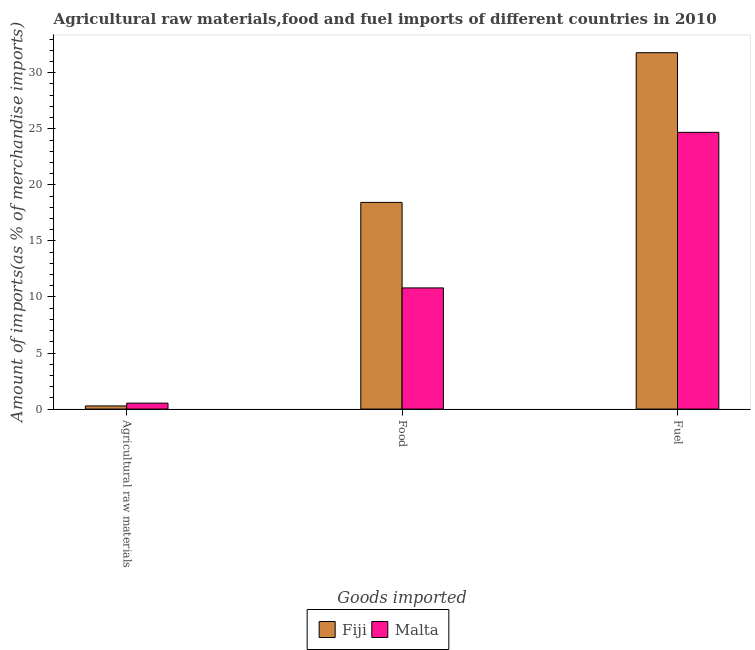How many groups of bars are there?
Give a very brief answer. 3. Are the number of bars per tick equal to the number of legend labels?
Your answer should be compact. Yes. How many bars are there on the 3rd tick from the left?
Your answer should be compact. 2. How many bars are there on the 2nd tick from the right?
Offer a very short reply. 2. What is the label of the 1st group of bars from the left?
Offer a terse response. Agricultural raw materials. What is the percentage of fuel imports in Fiji?
Your response must be concise. 31.79. Across all countries, what is the maximum percentage of raw materials imports?
Your response must be concise. 0.53. Across all countries, what is the minimum percentage of raw materials imports?
Offer a very short reply. 0.28. In which country was the percentage of raw materials imports maximum?
Your answer should be very brief. Malta. In which country was the percentage of raw materials imports minimum?
Keep it short and to the point. Fiji. What is the total percentage of food imports in the graph?
Make the answer very short. 29.24. What is the difference between the percentage of raw materials imports in Malta and that in Fiji?
Offer a very short reply. 0.25. What is the difference between the percentage of fuel imports in Fiji and the percentage of raw materials imports in Malta?
Your answer should be very brief. 31.26. What is the average percentage of raw materials imports per country?
Your answer should be very brief. 0.41. What is the difference between the percentage of raw materials imports and percentage of fuel imports in Malta?
Make the answer very short. -24.15. What is the ratio of the percentage of fuel imports in Malta to that in Fiji?
Make the answer very short. 0.78. Is the percentage of food imports in Malta less than that in Fiji?
Ensure brevity in your answer.  Yes. What is the difference between the highest and the second highest percentage of food imports?
Offer a terse response. 7.63. What is the difference between the highest and the lowest percentage of food imports?
Offer a very short reply. 7.63. In how many countries, is the percentage of fuel imports greater than the average percentage of fuel imports taken over all countries?
Your answer should be very brief. 1. What does the 2nd bar from the left in Food represents?
Provide a succinct answer. Malta. What does the 2nd bar from the right in Agricultural raw materials represents?
Your answer should be compact. Fiji. How many bars are there?
Provide a succinct answer. 6. Are all the bars in the graph horizontal?
Make the answer very short. No. What is the difference between two consecutive major ticks on the Y-axis?
Your answer should be compact. 5. Are the values on the major ticks of Y-axis written in scientific E-notation?
Keep it short and to the point. No. Does the graph contain grids?
Your answer should be very brief. No. Where does the legend appear in the graph?
Your answer should be compact. Bottom center. How many legend labels are there?
Your answer should be compact. 2. What is the title of the graph?
Keep it short and to the point. Agricultural raw materials,food and fuel imports of different countries in 2010. What is the label or title of the X-axis?
Keep it short and to the point. Goods imported. What is the label or title of the Y-axis?
Offer a very short reply. Amount of imports(as % of merchandise imports). What is the Amount of imports(as % of merchandise imports) of Fiji in Agricultural raw materials?
Your answer should be very brief. 0.28. What is the Amount of imports(as % of merchandise imports) of Malta in Agricultural raw materials?
Offer a very short reply. 0.53. What is the Amount of imports(as % of merchandise imports) in Fiji in Food?
Your response must be concise. 18.43. What is the Amount of imports(as % of merchandise imports) of Malta in Food?
Offer a very short reply. 10.81. What is the Amount of imports(as % of merchandise imports) in Fiji in Fuel?
Provide a succinct answer. 31.79. What is the Amount of imports(as % of merchandise imports) of Malta in Fuel?
Your answer should be compact. 24.68. Across all Goods imported, what is the maximum Amount of imports(as % of merchandise imports) of Fiji?
Your answer should be compact. 31.79. Across all Goods imported, what is the maximum Amount of imports(as % of merchandise imports) in Malta?
Offer a terse response. 24.68. Across all Goods imported, what is the minimum Amount of imports(as % of merchandise imports) of Fiji?
Make the answer very short. 0.28. Across all Goods imported, what is the minimum Amount of imports(as % of merchandise imports) of Malta?
Provide a short and direct response. 0.53. What is the total Amount of imports(as % of merchandise imports) of Fiji in the graph?
Your answer should be compact. 50.5. What is the total Amount of imports(as % of merchandise imports) in Malta in the graph?
Your answer should be very brief. 36.02. What is the difference between the Amount of imports(as % of merchandise imports) in Fiji in Agricultural raw materials and that in Food?
Ensure brevity in your answer.  -18.15. What is the difference between the Amount of imports(as % of merchandise imports) in Malta in Agricultural raw materials and that in Food?
Your answer should be very brief. -10.28. What is the difference between the Amount of imports(as % of merchandise imports) of Fiji in Agricultural raw materials and that in Fuel?
Your answer should be very brief. -31.51. What is the difference between the Amount of imports(as % of merchandise imports) of Malta in Agricultural raw materials and that in Fuel?
Provide a short and direct response. -24.15. What is the difference between the Amount of imports(as % of merchandise imports) of Fiji in Food and that in Fuel?
Offer a terse response. -13.35. What is the difference between the Amount of imports(as % of merchandise imports) in Malta in Food and that in Fuel?
Ensure brevity in your answer.  -13.87. What is the difference between the Amount of imports(as % of merchandise imports) in Fiji in Agricultural raw materials and the Amount of imports(as % of merchandise imports) in Malta in Food?
Keep it short and to the point. -10.53. What is the difference between the Amount of imports(as % of merchandise imports) in Fiji in Agricultural raw materials and the Amount of imports(as % of merchandise imports) in Malta in Fuel?
Your answer should be very brief. -24.4. What is the difference between the Amount of imports(as % of merchandise imports) of Fiji in Food and the Amount of imports(as % of merchandise imports) of Malta in Fuel?
Make the answer very short. -6.25. What is the average Amount of imports(as % of merchandise imports) of Fiji per Goods imported?
Provide a succinct answer. 16.83. What is the average Amount of imports(as % of merchandise imports) in Malta per Goods imported?
Ensure brevity in your answer.  12.01. What is the difference between the Amount of imports(as % of merchandise imports) in Fiji and Amount of imports(as % of merchandise imports) in Malta in Agricultural raw materials?
Give a very brief answer. -0.25. What is the difference between the Amount of imports(as % of merchandise imports) in Fiji and Amount of imports(as % of merchandise imports) in Malta in Food?
Make the answer very short. 7.63. What is the difference between the Amount of imports(as % of merchandise imports) in Fiji and Amount of imports(as % of merchandise imports) in Malta in Fuel?
Offer a terse response. 7.11. What is the ratio of the Amount of imports(as % of merchandise imports) in Fiji in Agricultural raw materials to that in Food?
Provide a short and direct response. 0.02. What is the ratio of the Amount of imports(as % of merchandise imports) in Malta in Agricultural raw materials to that in Food?
Provide a succinct answer. 0.05. What is the ratio of the Amount of imports(as % of merchandise imports) in Fiji in Agricultural raw materials to that in Fuel?
Offer a terse response. 0.01. What is the ratio of the Amount of imports(as % of merchandise imports) of Malta in Agricultural raw materials to that in Fuel?
Provide a succinct answer. 0.02. What is the ratio of the Amount of imports(as % of merchandise imports) in Fiji in Food to that in Fuel?
Ensure brevity in your answer.  0.58. What is the ratio of the Amount of imports(as % of merchandise imports) of Malta in Food to that in Fuel?
Provide a succinct answer. 0.44. What is the difference between the highest and the second highest Amount of imports(as % of merchandise imports) of Fiji?
Your answer should be compact. 13.35. What is the difference between the highest and the second highest Amount of imports(as % of merchandise imports) of Malta?
Your answer should be compact. 13.87. What is the difference between the highest and the lowest Amount of imports(as % of merchandise imports) of Fiji?
Your answer should be compact. 31.51. What is the difference between the highest and the lowest Amount of imports(as % of merchandise imports) of Malta?
Your answer should be compact. 24.15. 